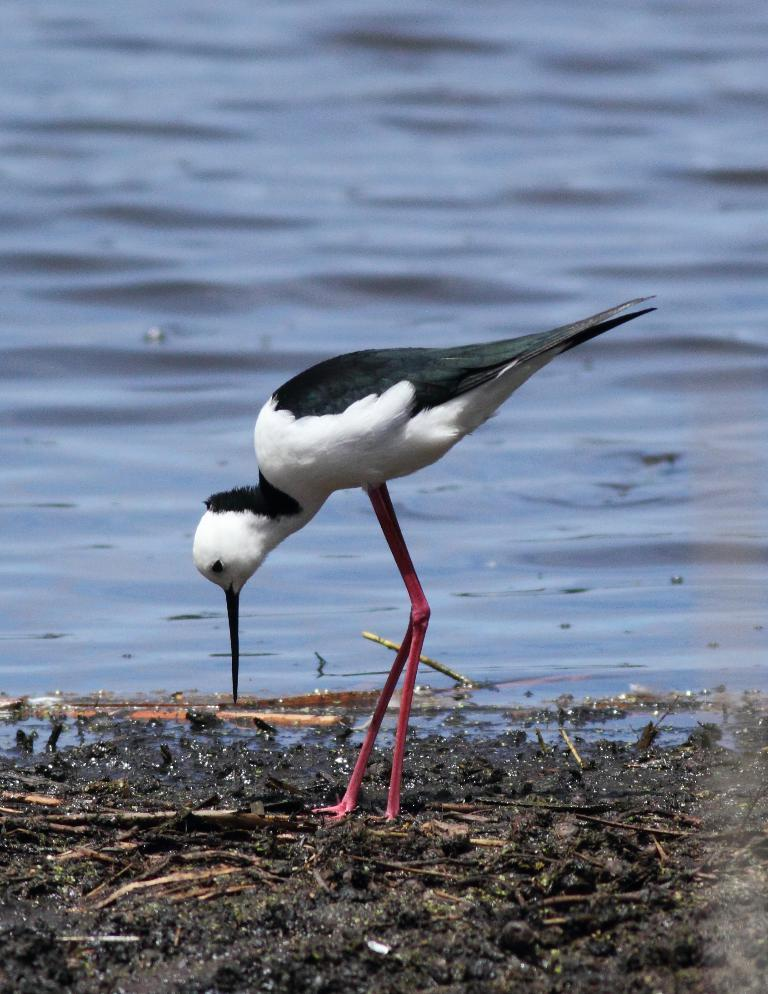What type of animal is in the picture? There is a bird in the picture. Can you describe the bird's legs? The bird has long legs. What surface is the bird standing on? The bird is standing on a mud surface. How would you describe the bird's color? The bird is white in color with some black parts. What can be seen near the bird? There is water visible near the bird. What type of kettle is the bird using to boil water in the image? There is no kettle present in the image, and the bird is not using any object to boil water. 